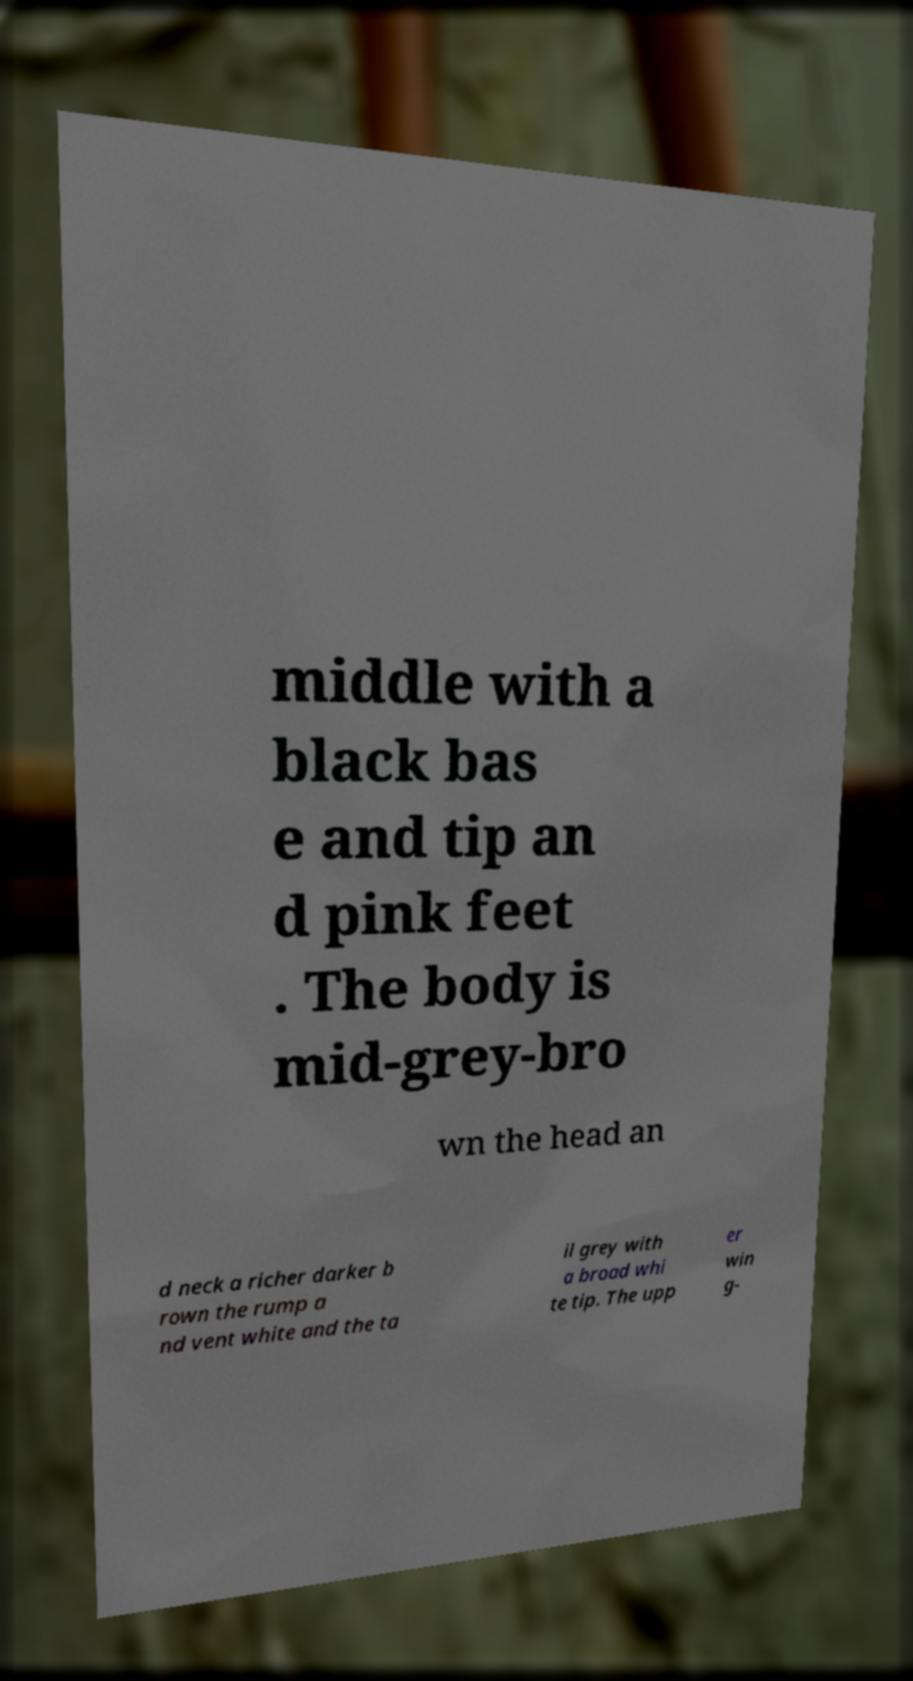There's text embedded in this image that I need extracted. Can you transcribe it verbatim? middle with a black bas e and tip an d pink feet . The body is mid-grey-bro wn the head an d neck a richer darker b rown the rump a nd vent white and the ta il grey with a broad whi te tip. The upp er win g- 